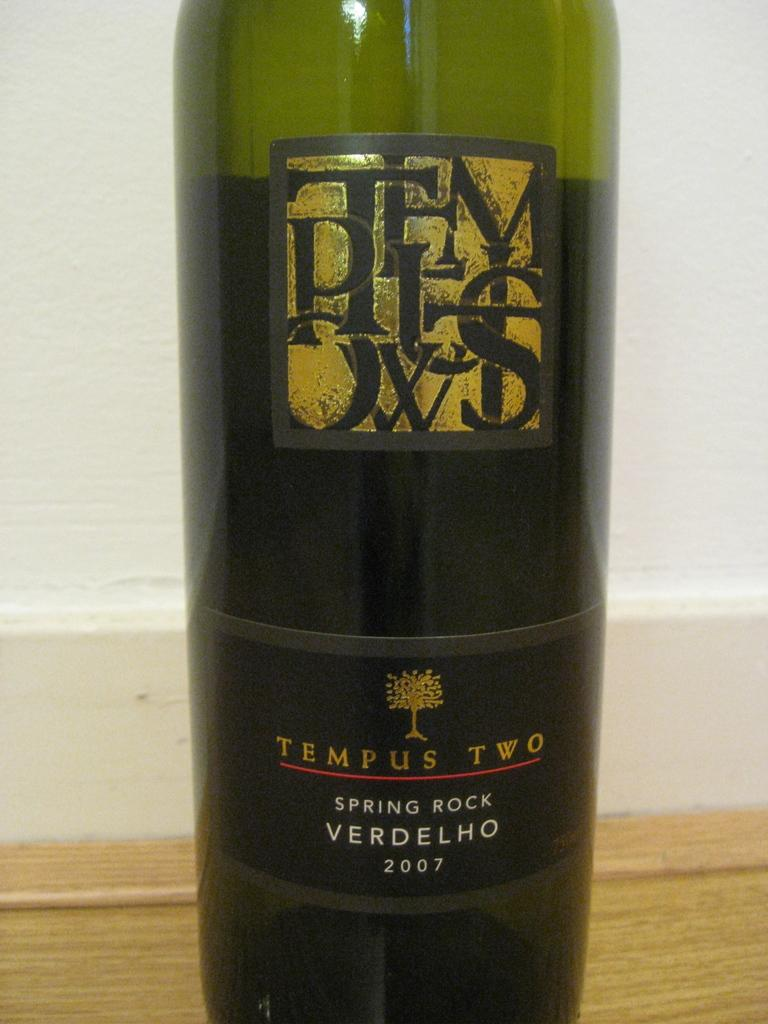<image>
Write a terse but informative summary of the picture. Bottle of alcohol which says the words Tempus Two near the bottom. 